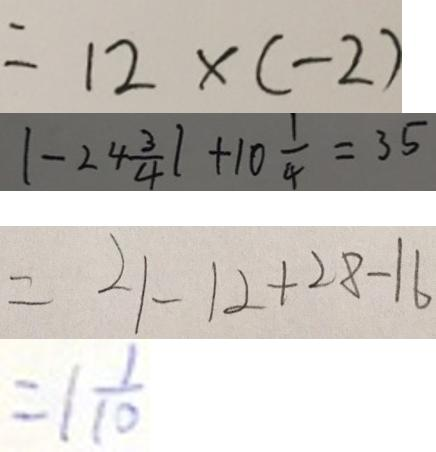Convert formula to latex. <formula><loc_0><loc_0><loc_500><loc_500>= 1 2 \times ( - 2 ) 
 \vert - 2 4 \frac { 3 } { 4 } \vert + 1 0 \frac { 1 } { 4 } = 3 5 
 = 2 1 - 1 2 + 2 8 - 1 6 
 = 1 \frac { 1 } { 1 0 }</formula> 